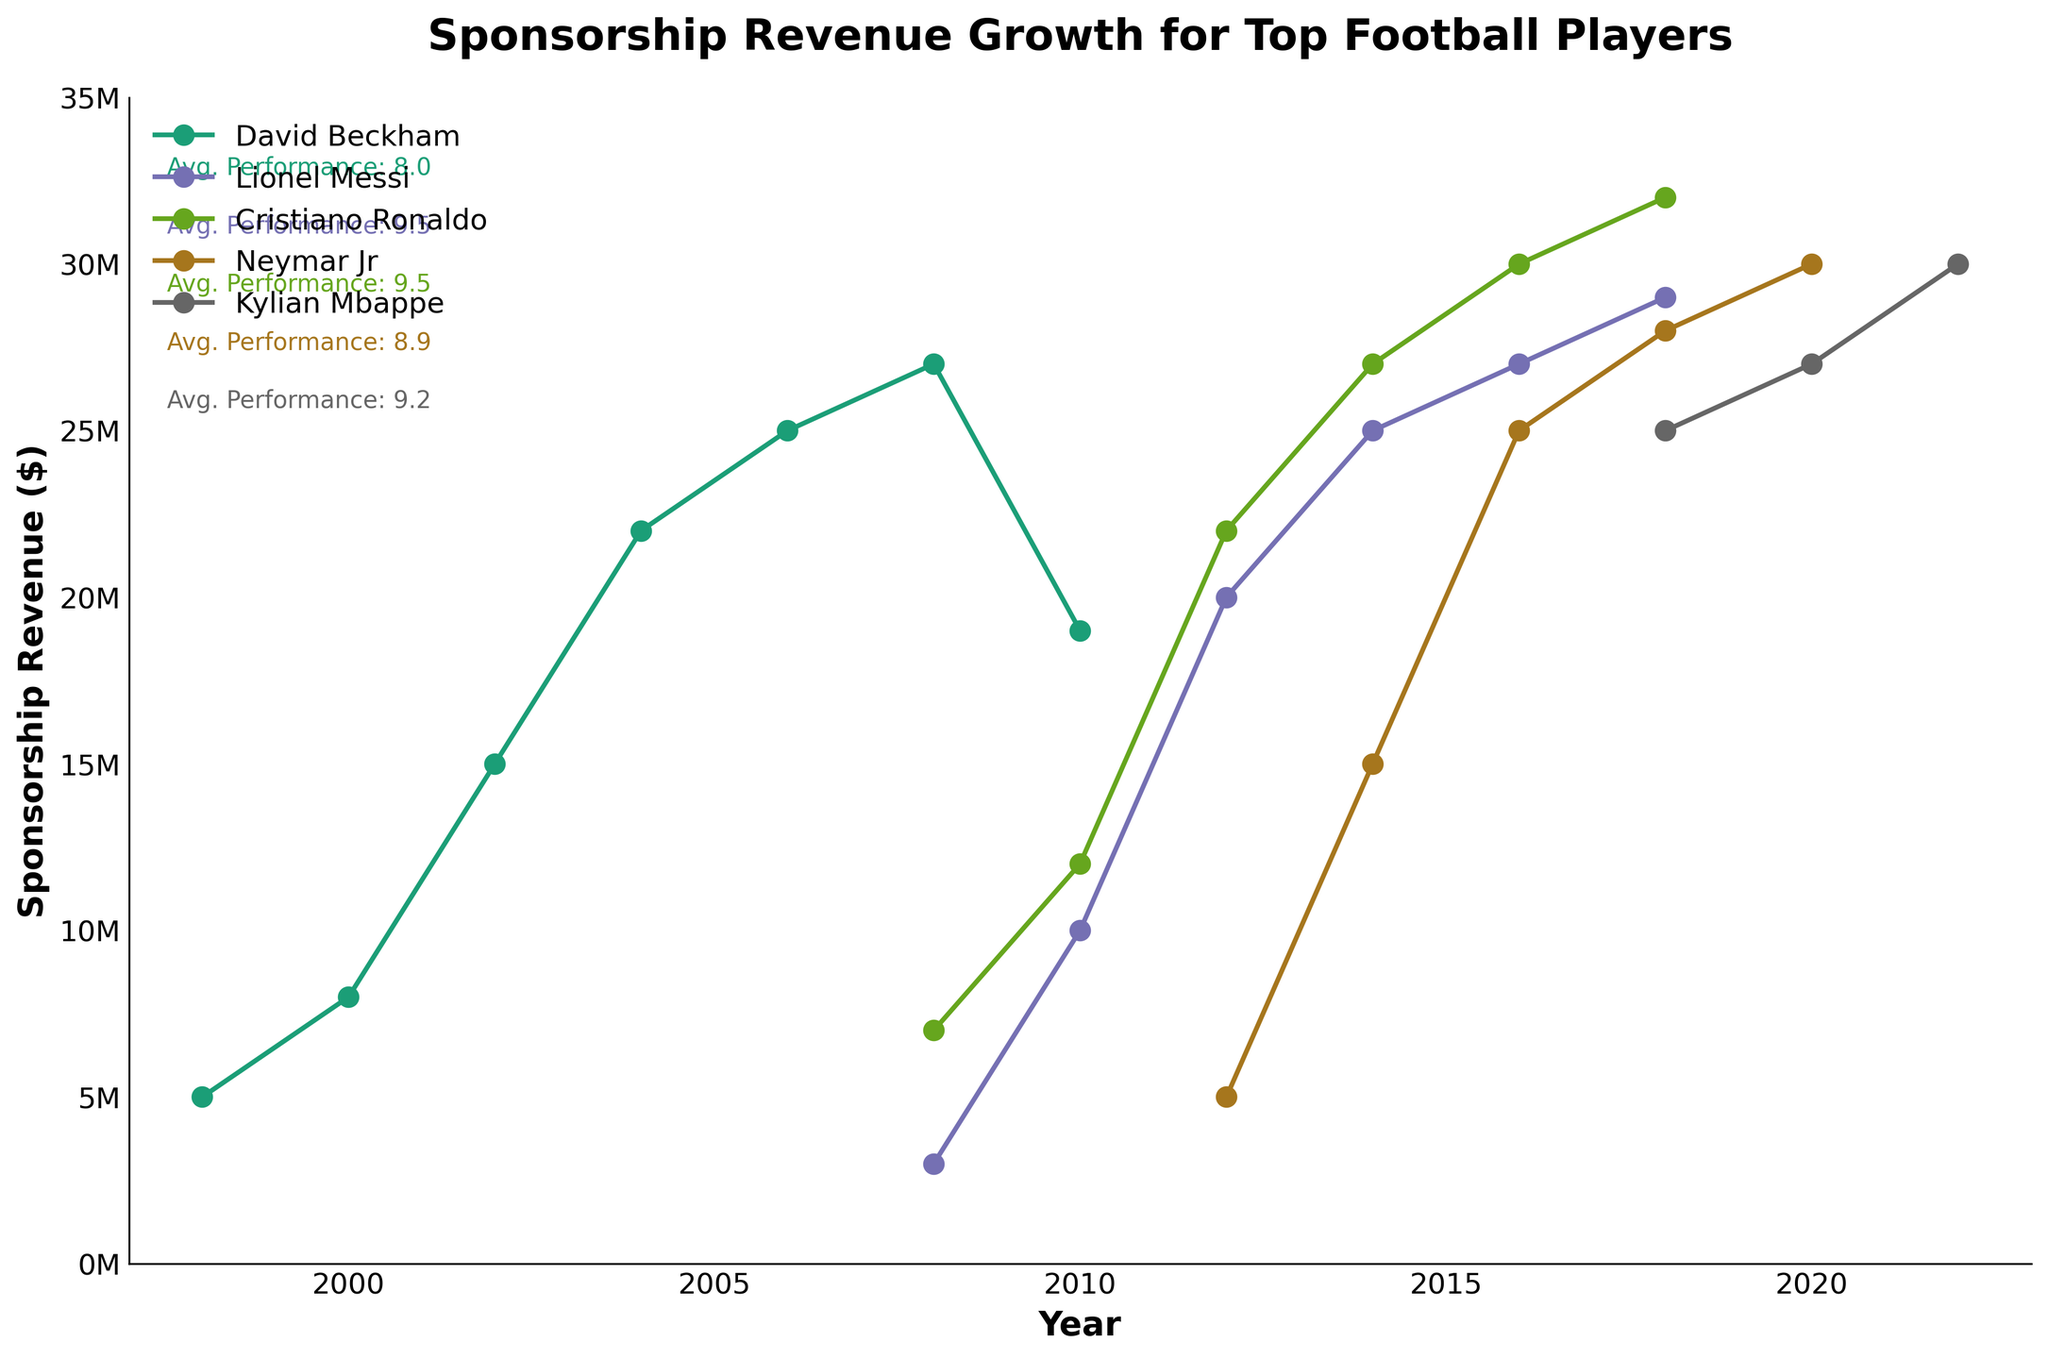What's the title of the figure? The title is usually located at the top center of the figure.
Answer: Sponsorship Revenue Growth for Top Football Players What's the time range shown on the x-axis? The x-axis represents years and usually has the minimum and maximum year labeled on the ends.
Answer: 1997 to 2023 Which player has the highest sponsorship revenue in the year 2018? Looking at the intersection of player lines with the year 2018 on the x-axis and checking the corresponding y-axis sponsorship revenue values.
Answer: Cristiano Ronaldo Compare the sponsorship revenue of David Beckham and Lionel Messi in 2008. Who earned more? Look at the y-values for David Beckham and Lionel Messi at 2008 on the x-axis and compare them.
Answer: David Beckham What's the average performance rating for Neymar Jr? The figure has annotations with average performance ratings for each player; look for Neymar Jr.'s annotation.
Answer: 8.9 What's the sponsorship revenue growth for Lionel Messi from 2008 to 2010? Check the sponsorship revenue values for Lionel Messi in 2008 and 2010 and calculate the difference.
Answer: $7,000,000 Who has the most consistent sponsorship revenue growth over the period shown? Look for the player with a steady, largely upward sloping line on the plot without significant dips.
Answer: Cristiano Ronaldo How did Kylian Mbappe's sponsorship revenue in 2020 compare to his revenue in 2018? Look at the y-values for Kylian Mbappe at 2018 and 2020 on the x-axis and compare them.
Answer: Higher in 2020 by $2,000,000 Which player had the largest sponsorship revenue in 2012? Check the y-values for all players at the year 2012 on the x-axis and identify the one with the highest value.
Answer: Cristiano Ronaldo What's the general trend in sponsorship revenues over the years for all players? Observing all lines from left to right on the plot, noting if they generally increase, decrease, or vary.
Answer: Generally increasing 